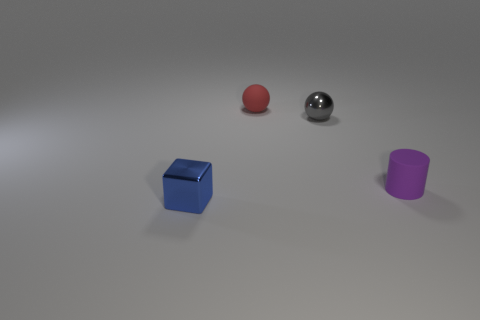Can you describe the colors and materials of the objects in the image? Certainly! In the image, there are four key objects. From left to right: a blue cube with a somewhat reflective surface suggesting a plastic material, a matte red ball, a shiny metallic ball that reflects the environment, and a matte purple cylinder. 